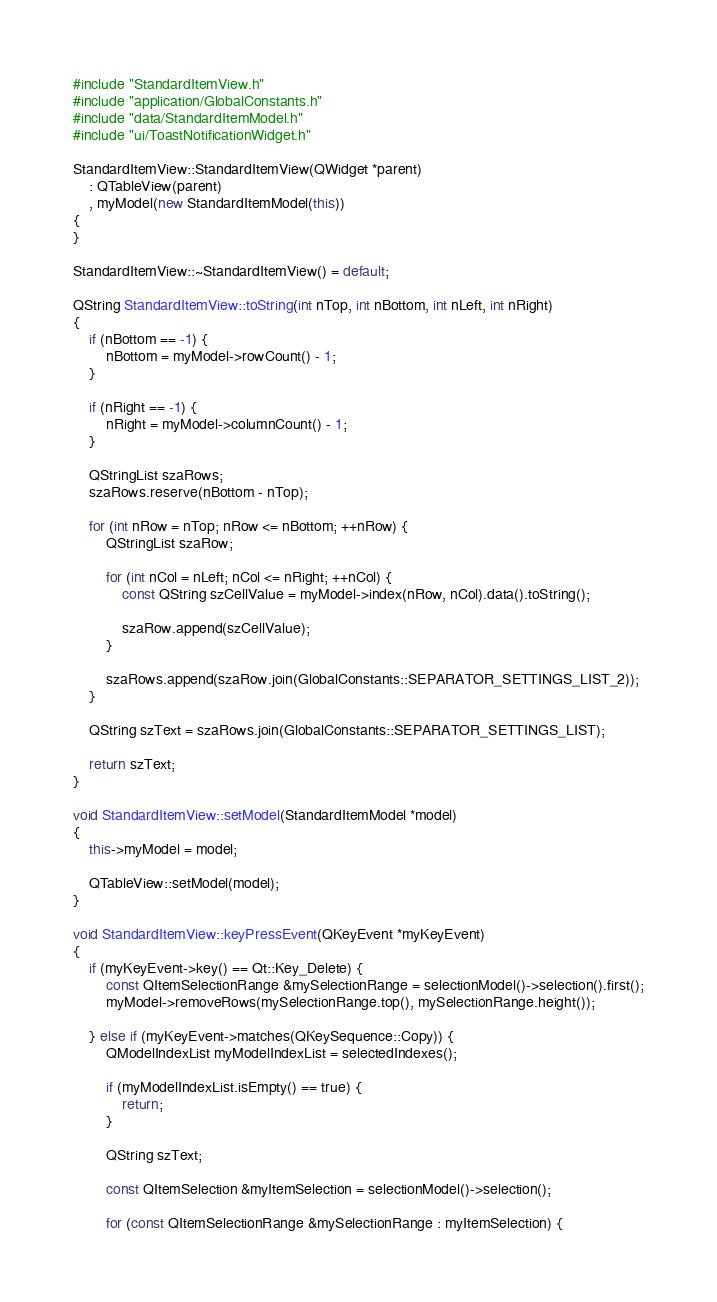Convert code to text. <code><loc_0><loc_0><loc_500><loc_500><_C++_>#include "StandardItemView.h"
#include "application/GlobalConstants.h"
#include "data/StandardItemModel.h"
#include "ui/ToastNotificationWidget.h"

StandardItemView::StandardItemView(QWidget *parent)
    : QTableView(parent)
    , myModel(new StandardItemModel(this))
{
}

StandardItemView::~StandardItemView() = default;

QString StandardItemView::toString(int nTop, int nBottom, int nLeft, int nRight)
{
    if (nBottom == -1) {
        nBottom = myModel->rowCount() - 1;
    }

    if (nRight == -1) {
        nRight = myModel->columnCount() - 1;
    }

    QStringList szaRows;
    szaRows.reserve(nBottom - nTop);

    for (int nRow = nTop; nRow <= nBottom; ++nRow) {
        QStringList szaRow;

        for (int nCol = nLeft; nCol <= nRight; ++nCol) {
            const QString szCellValue = myModel->index(nRow, nCol).data().toString();

            szaRow.append(szCellValue);
        }

        szaRows.append(szaRow.join(GlobalConstants::SEPARATOR_SETTINGS_LIST_2));
    }

    QString szText = szaRows.join(GlobalConstants::SEPARATOR_SETTINGS_LIST);

    return szText;
}

void StandardItemView::setModel(StandardItemModel *model)
{
    this->myModel = model;

    QTableView::setModel(model);
}

void StandardItemView::keyPressEvent(QKeyEvent *myKeyEvent)
{
    if (myKeyEvent->key() == Qt::Key_Delete) {
        const QItemSelectionRange &mySelectionRange = selectionModel()->selection().first();
        myModel->removeRows(mySelectionRange.top(), mySelectionRange.height());

    } else if (myKeyEvent->matches(QKeySequence::Copy)) {
        QModelIndexList myModelIndexList = selectedIndexes();

        if (myModelIndexList.isEmpty() == true) {
            return;
        }

        QString szText;

        const QItemSelection &myItemSelection = selectionModel()->selection();

        for (const QItemSelectionRange &mySelectionRange : myItemSelection) {</code> 